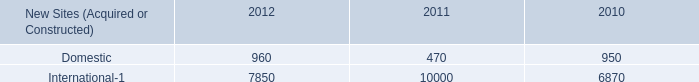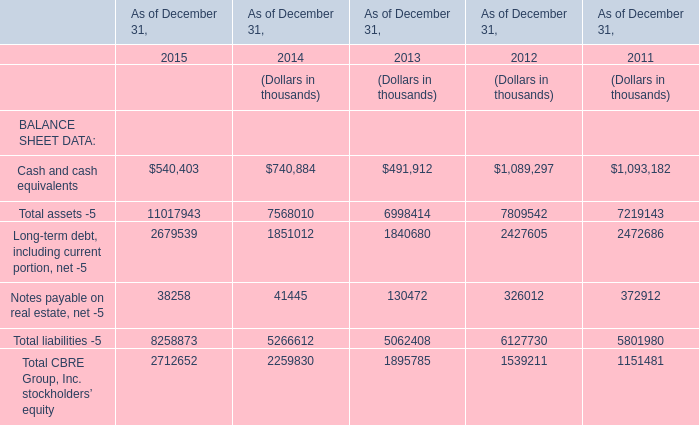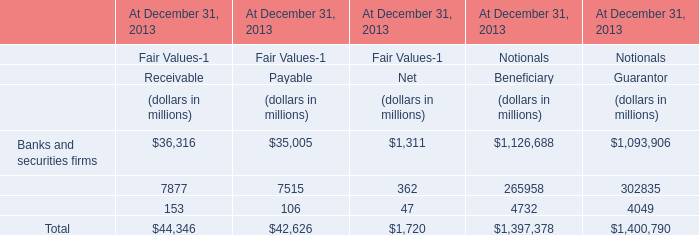What is the average value of Banks and securities firms for Receivable and Cash and cash equivalents for BALANCE SHEET DATA in 2015 ? 
Computations: ((540403 + 36316) / 2)
Answer: 288359.5. 